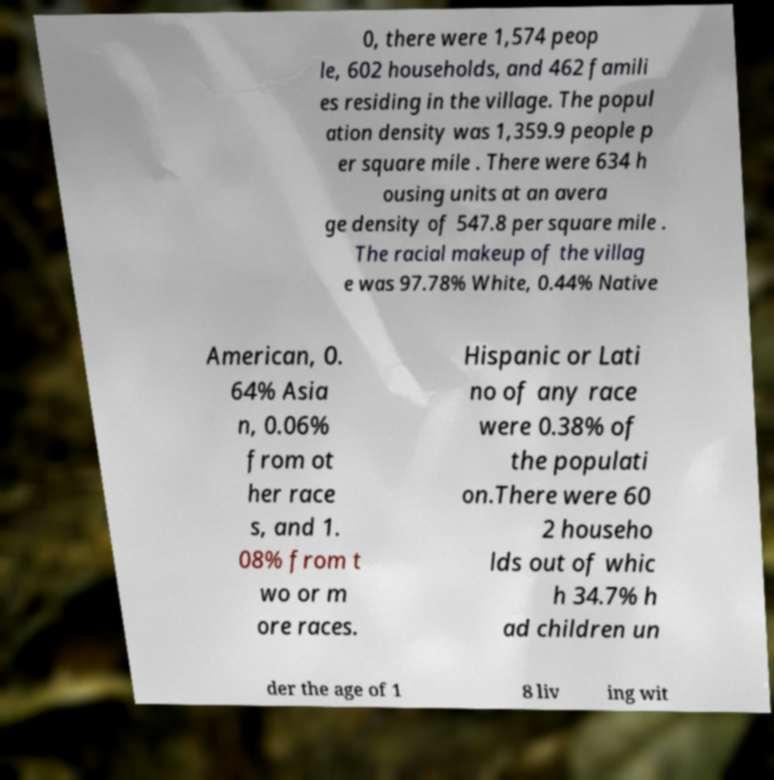For documentation purposes, I need the text within this image transcribed. Could you provide that? 0, there were 1,574 peop le, 602 households, and 462 famili es residing in the village. The popul ation density was 1,359.9 people p er square mile . There were 634 h ousing units at an avera ge density of 547.8 per square mile . The racial makeup of the villag e was 97.78% White, 0.44% Native American, 0. 64% Asia n, 0.06% from ot her race s, and 1. 08% from t wo or m ore races. Hispanic or Lati no of any race were 0.38% of the populati on.There were 60 2 househo lds out of whic h 34.7% h ad children un der the age of 1 8 liv ing wit 